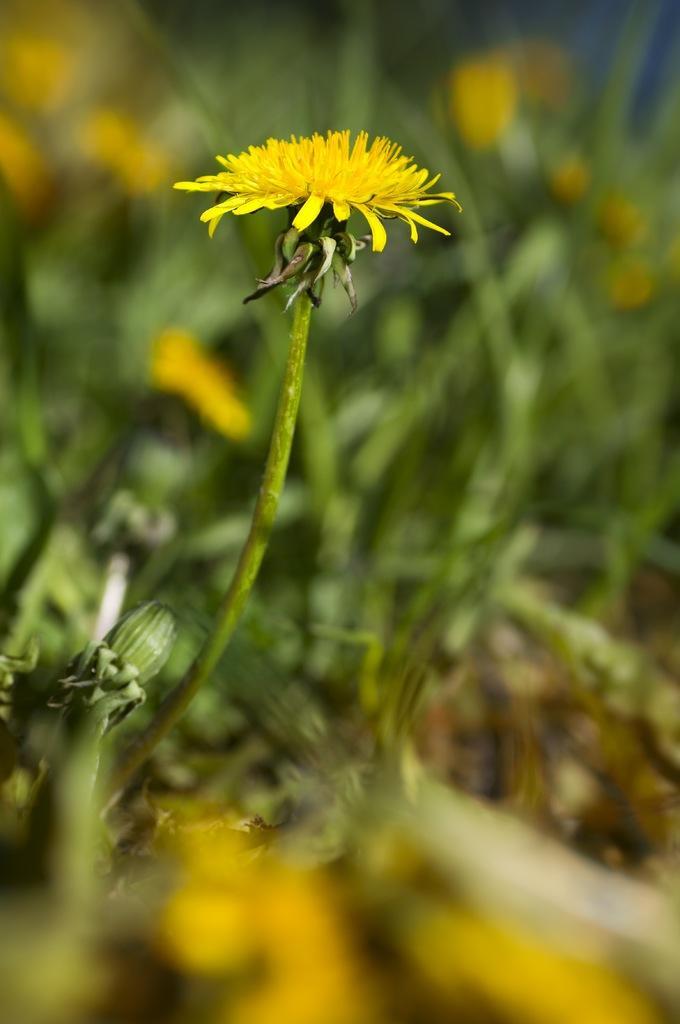Please provide a concise description of this image. In this image we can see many plants. There are many flowers to the plants 